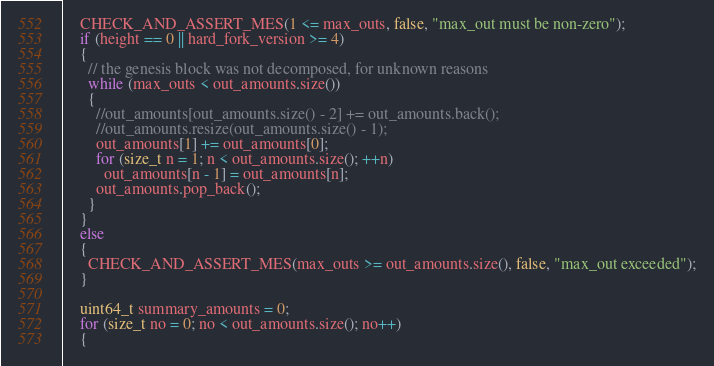Convert code to text. <code><loc_0><loc_0><loc_500><loc_500><_C++_>    CHECK_AND_ASSERT_MES(1 <= max_outs, false, "max_out must be non-zero");
    if (height == 0 || hard_fork_version >= 4)
    {
      // the genesis block was not decomposed, for unknown reasons
      while (max_outs < out_amounts.size())
      {
        //out_amounts[out_amounts.size() - 2] += out_amounts.back();
        //out_amounts.resize(out_amounts.size() - 1);
        out_amounts[1] += out_amounts[0];
        for (size_t n = 1; n < out_amounts.size(); ++n)
          out_amounts[n - 1] = out_amounts[n];
        out_amounts.pop_back();
      }
    }
    else
    {
      CHECK_AND_ASSERT_MES(max_outs >= out_amounts.size(), false, "max_out exceeded");
    }

    uint64_t summary_amounts = 0;
    for (size_t no = 0; no < out_amounts.size(); no++)
    {</code> 